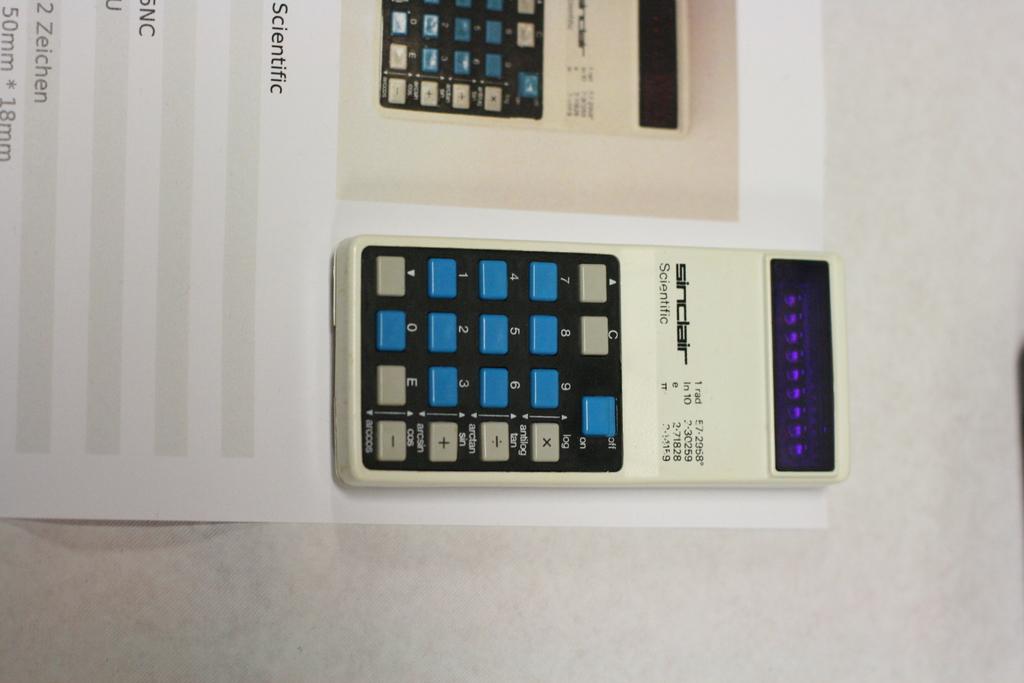Is this a scientific calculator or not?
Make the answer very short. Answering does not require reading text in the image. 